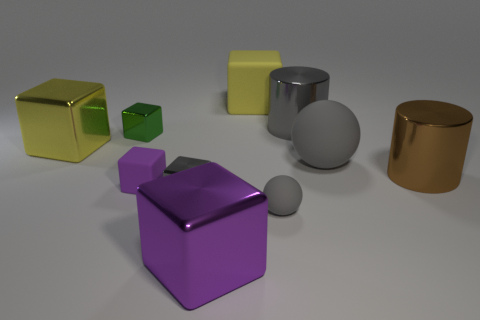Subtract 2 blocks. How many blocks are left? 4 Subtract all yellow blocks. How many blocks are left? 4 Subtract all large purple cubes. How many cubes are left? 5 Subtract all cyan blocks. Subtract all cyan cylinders. How many blocks are left? 6 Subtract all cubes. How many objects are left? 4 Add 6 gray spheres. How many gray spheres exist? 8 Subtract 0 red balls. How many objects are left? 10 Subtract all purple rubber blocks. Subtract all metal cubes. How many objects are left? 5 Add 2 yellow cubes. How many yellow cubes are left? 4 